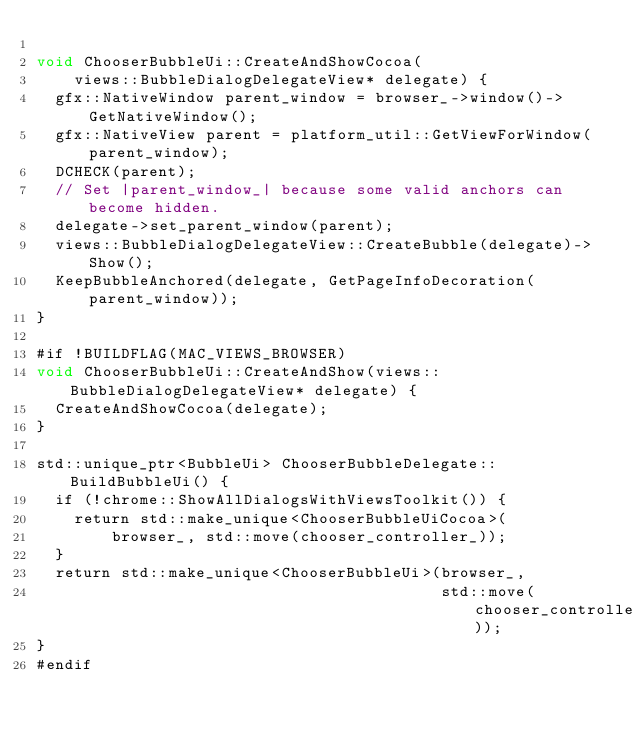<code> <loc_0><loc_0><loc_500><loc_500><_ObjectiveC_>
void ChooserBubbleUi::CreateAndShowCocoa(
    views::BubbleDialogDelegateView* delegate) {
  gfx::NativeWindow parent_window = browser_->window()->GetNativeWindow();
  gfx::NativeView parent = platform_util::GetViewForWindow(parent_window);
  DCHECK(parent);
  // Set |parent_window_| because some valid anchors can become hidden.
  delegate->set_parent_window(parent);
  views::BubbleDialogDelegateView::CreateBubble(delegate)->Show();
  KeepBubbleAnchored(delegate, GetPageInfoDecoration(parent_window));
}

#if !BUILDFLAG(MAC_VIEWS_BROWSER)
void ChooserBubbleUi::CreateAndShow(views::BubbleDialogDelegateView* delegate) {
  CreateAndShowCocoa(delegate);
}

std::unique_ptr<BubbleUi> ChooserBubbleDelegate::BuildBubbleUi() {
  if (!chrome::ShowAllDialogsWithViewsToolkit()) {
    return std::make_unique<ChooserBubbleUiCocoa>(
        browser_, std::move(chooser_controller_));
  }
  return std::make_unique<ChooserBubbleUi>(browser_,
                                           std::move(chooser_controller_));
}
#endif
</code> 